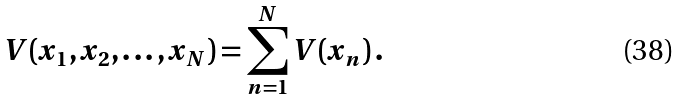<formula> <loc_0><loc_0><loc_500><loc_500>V ( x _ { 1 } , x _ { 2 } , \dots , x _ { N } ) = \sum _ { n = 1 } ^ { N } V ( x _ { n } ) \, .</formula> 